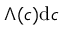<formula> <loc_0><loc_0><loc_500><loc_500>\Lambda ( c ) d c</formula> 